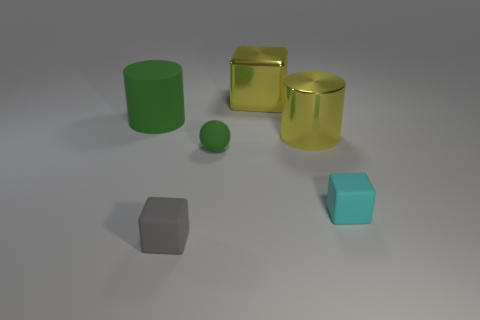Add 1 big yellow objects. How many objects exist? 7 Subtract all cylinders. How many objects are left? 4 Subtract 1 cyan blocks. How many objects are left? 5 Subtract all tiny brown rubber cylinders. Subtract all metal cubes. How many objects are left? 5 Add 1 green rubber cylinders. How many green rubber cylinders are left? 2 Add 3 cyan cubes. How many cyan cubes exist? 4 